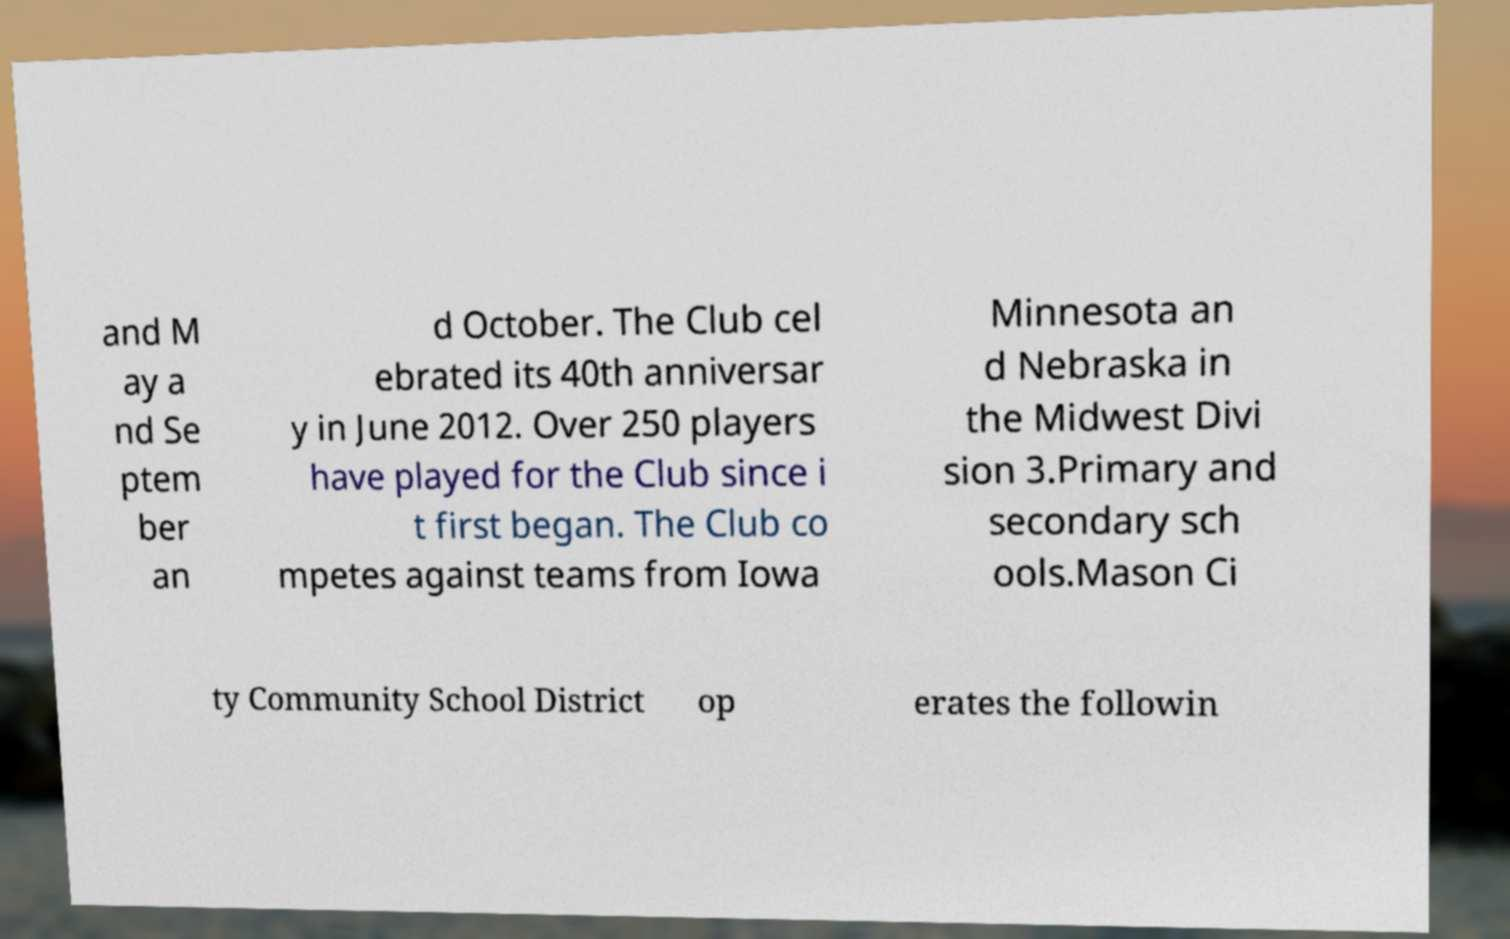For documentation purposes, I need the text within this image transcribed. Could you provide that? and M ay a nd Se ptem ber an d October. The Club cel ebrated its 40th anniversar y in June 2012. Over 250 players have played for the Club since i t first began. The Club co mpetes against teams from Iowa Minnesota an d Nebraska in the Midwest Divi sion 3.Primary and secondary sch ools.Mason Ci ty Community School District op erates the followin 